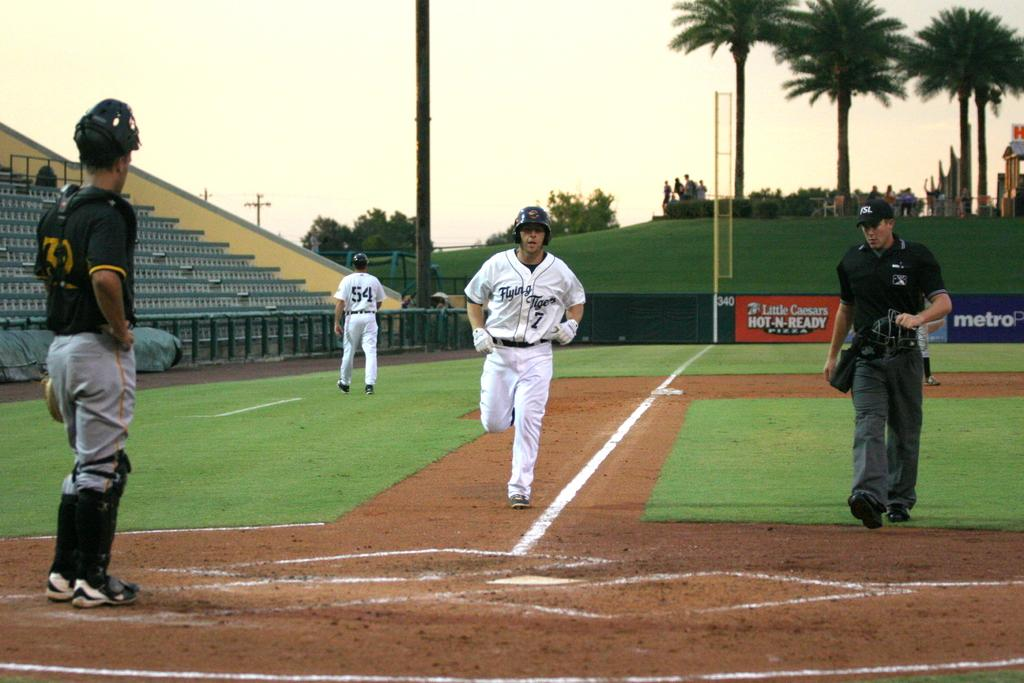Provide a one-sentence caption for the provided image. Number 7 of the Flying Tigers is running towards home plate. 